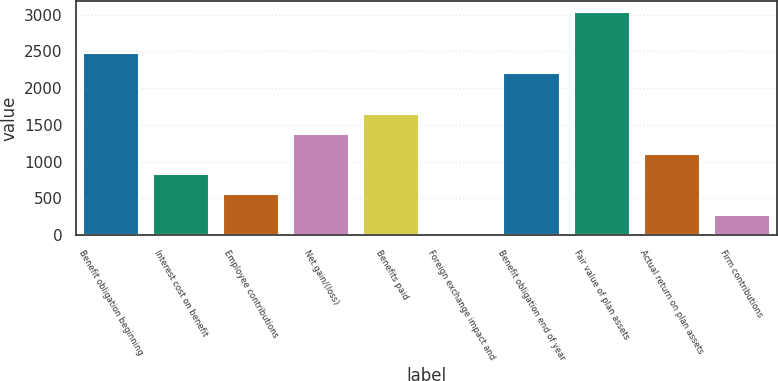Convert chart. <chart><loc_0><loc_0><loc_500><loc_500><bar_chart><fcel>Benefit obligation beginning<fcel>Interest cost on benefit<fcel>Employee contributions<fcel>Net gain/(loss)<fcel>Benefits paid<fcel>Foreign exchange impact and<fcel>Benefit obligation end of year<fcel>Fair value of plan assets<fcel>Actual return on plan assets<fcel>Firm contributions<nl><fcel>2481.5<fcel>828.5<fcel>553<fcel>1379.5<fcel>1655<fcel>2<fcel>2206<fcel>3032.5<fcel>1104<fcel>277.5<nl></chart> 